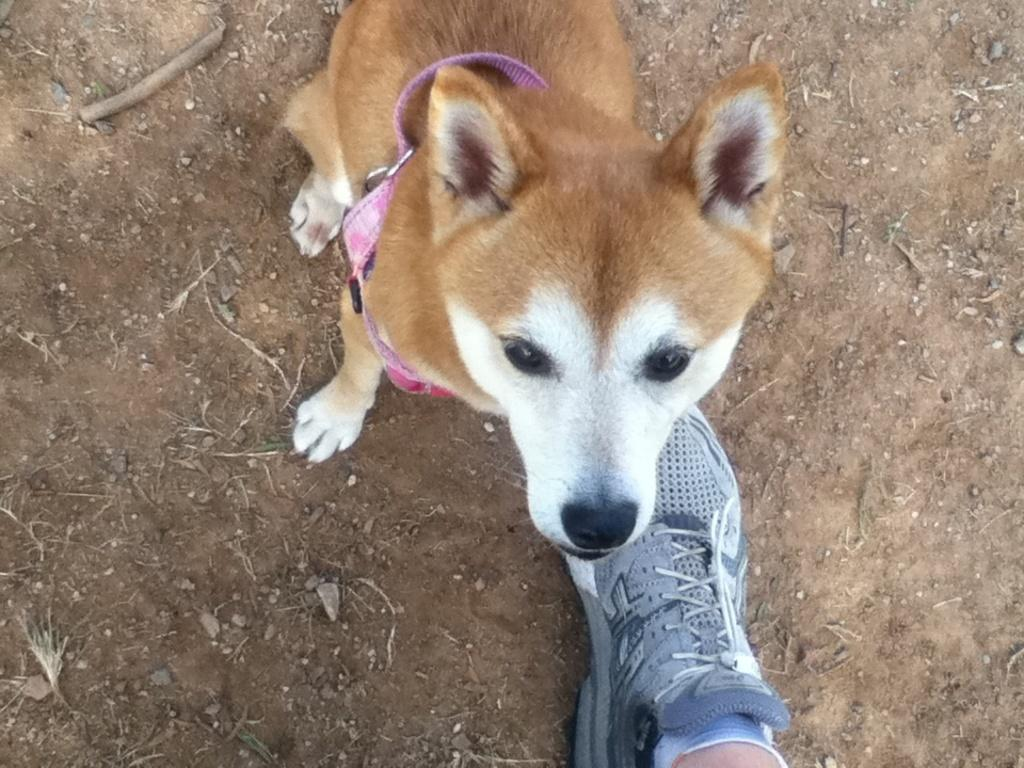What type of animal is in the image? There is a dog in the image. What is the dog wearing? The dog is wearing a dog belt. Can you describe any part of a person in the image? A leg of a person is visible at the bottom of the image, and it has a shoe on it. What direction is the flag blowing in the image? There is no flag present in the image. Can you tell me the brand of the pencil the dog is holding in the image? There is no pencil present in the image, and the dog is not holding anything. 